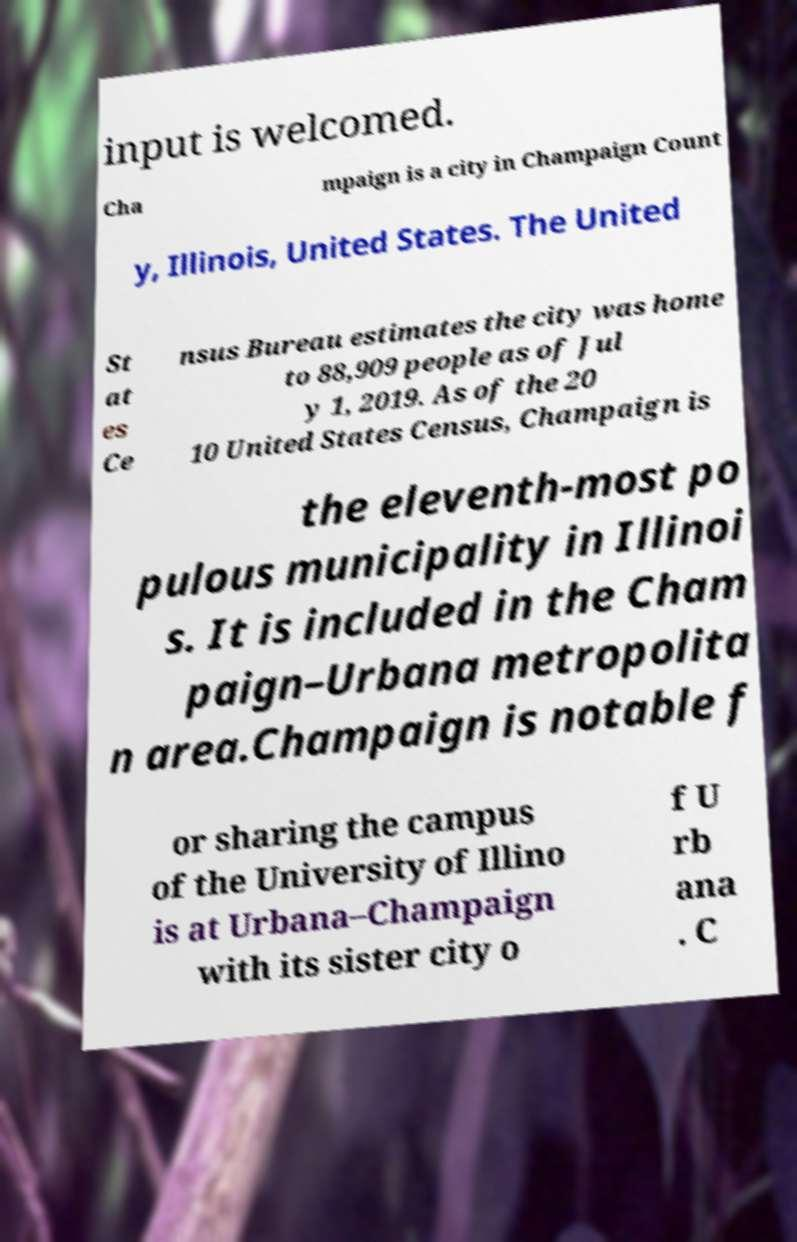Can you accurately transcribe the text from the provided image for me? input is welcomed. Cha mpaign is a city in Champaign Count y, Illinois, United States. The United St at es Ce nsus Bureau estimates the city was home to 88,909 people as of Jul y 1, 2019. As of the 20 10 United States Census, Champaign is the eleventh-most po pulous municipality in Illinoi s. It is included in the Cham paign–Urbana metropolita n area.Champaign is notable f or sharing the campus of the University of Illino is at Urbana–Champaign with its sister city o f U rb ana . C 